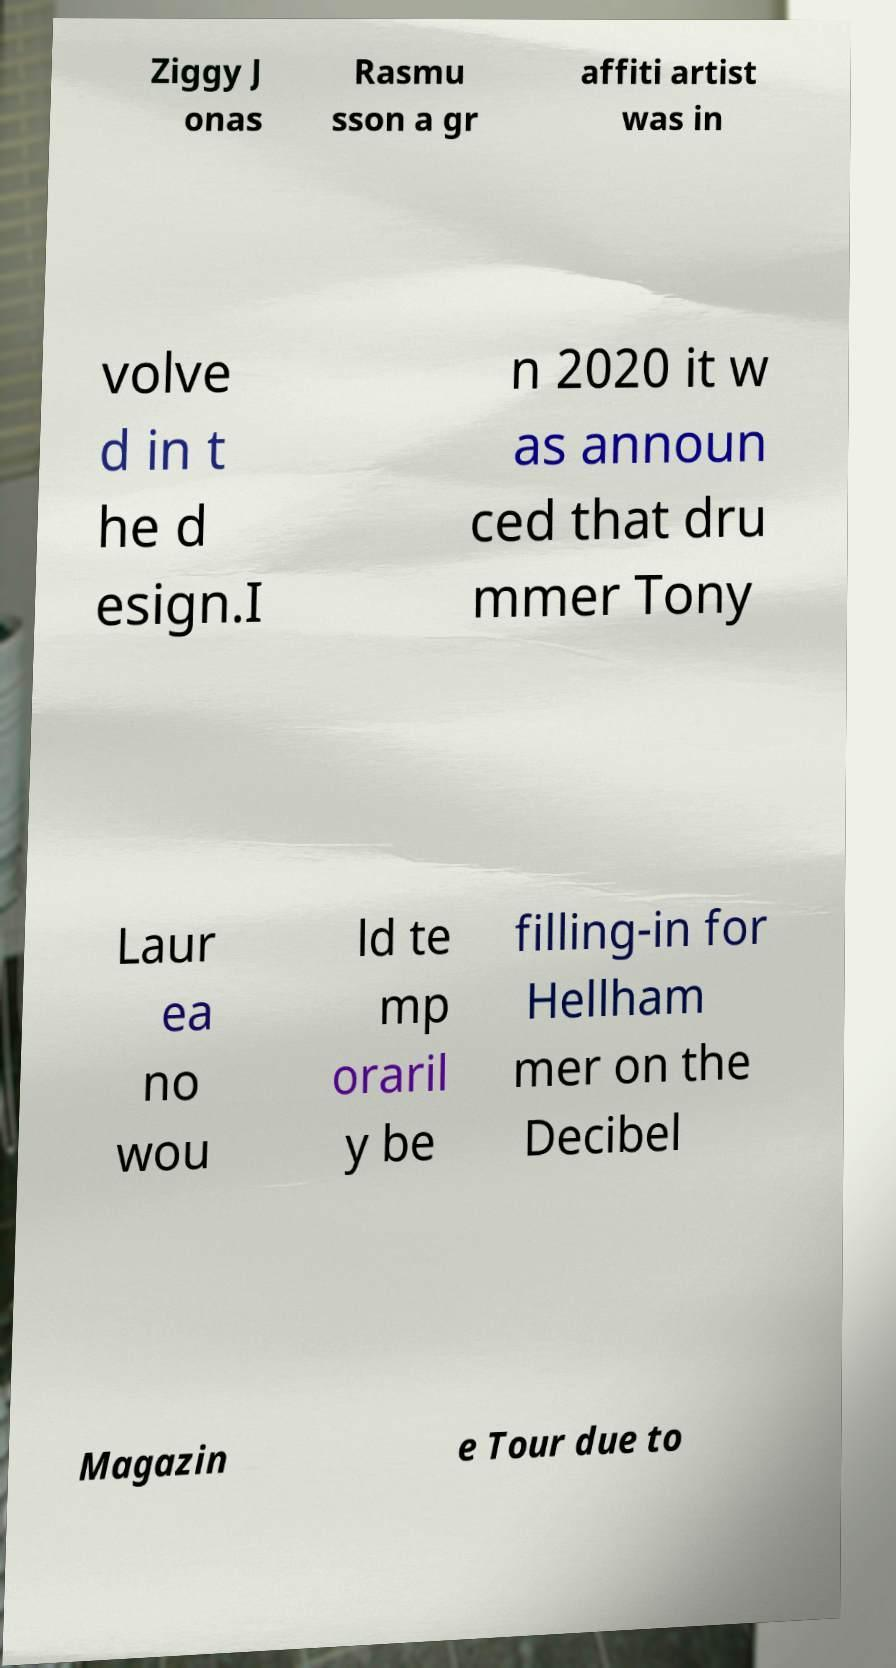Can you accurately transcribe the text from the provided image for me? Ziggy J onas Rasmu sson a gr affiti artist was in volve d in t he d esign.I n 2020 it w as announ ced that dru mmer Tony Laur ea no wou ld te mp oraril y be filling-in for Hellham mer on the Decibel Magazin e Tour due to 